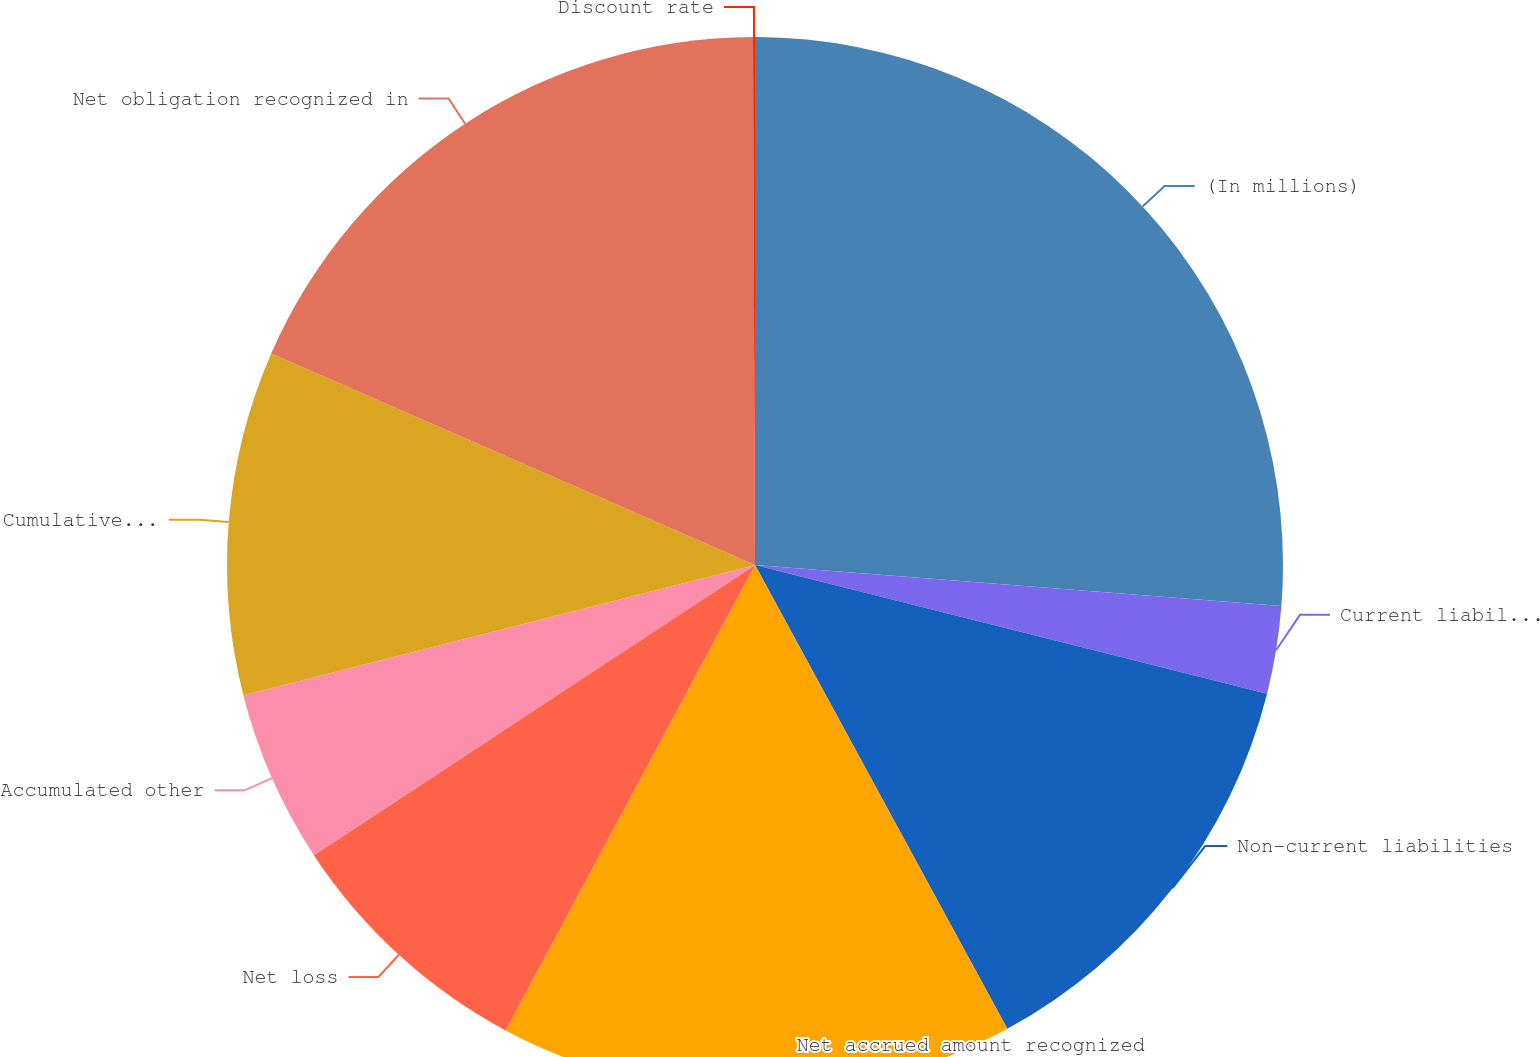<chart> <loc_0><loc_0><loc_500><loc_500><pie_chart><fcel>(In millions)<fcel>Current liabilities<fcel>Non-current liabilities<fcel>Net accrued amount recognized<fcel>Net loss<fcel>Accumulated other<fcel>Cumulative employer<fcel>Net obligation recognized in<fcel>Discount rate<nl><fcel>26.24%<fcel>2.68%<fcel>13.15%<fcel>15.76%<fcel>7.91%<fcel>5.29%<fcel>10.53%<fcel>18.38%<fcel>0.06%<nl></chart> 